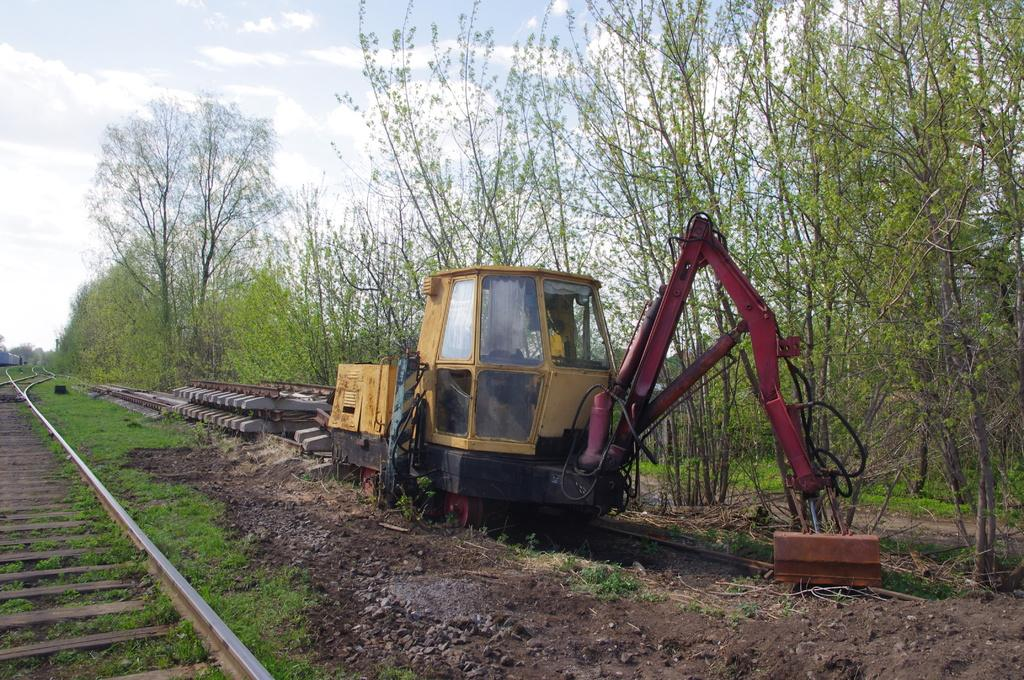What can be seen in the front of the image? There are trees, a vehicle, grass, and a train track in the front of the image. What type of objects are present in the front of the image? There are objects in the front of the image, but their specific nature is not mentioned in the facts. What is visible in the background of the image? The sky is visible in the background of the image. What is the condition of the sky in the image? The sky is cloudy in the image. Is the family mentioned in the image? There is no mention of a family in the image or the provided facts. Can you see a rabbit in the image? There is no rabbit present in the image. 